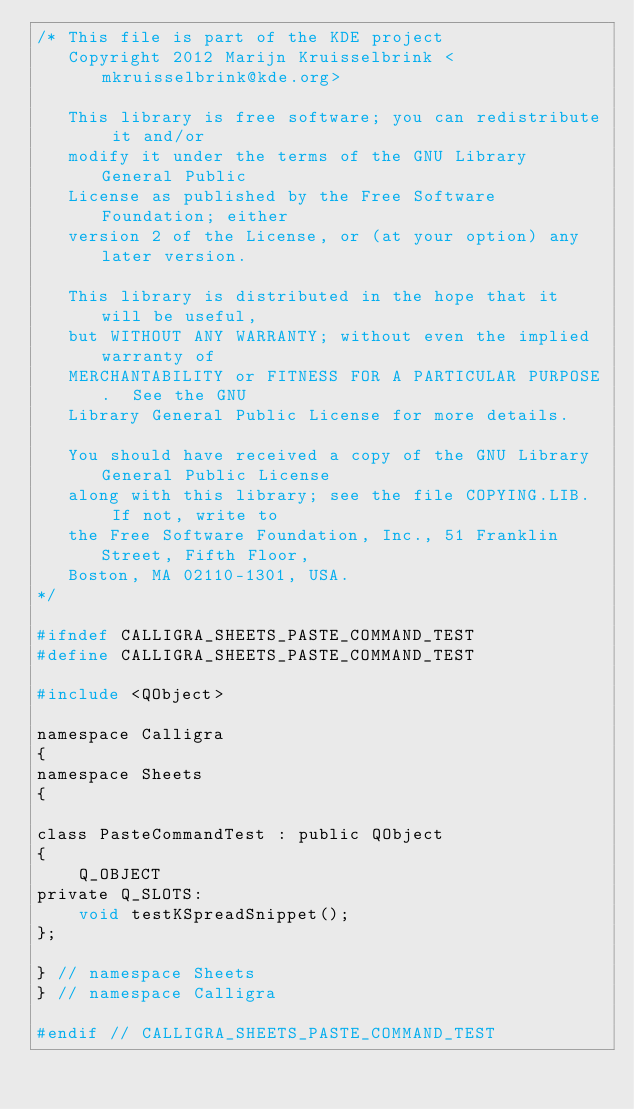Convert code to text. <code><loc_0><loc_0><loc_500><loc_500><_C_>/* This file is part of the KDE project
   Copyright 2012 Marijn Kruisselbrink <mkruisselbrink@kde.org>

   This library is free software; you can redistribute it and/or
   modify it under the terms of the GNU Library General Public
   License as published by the Free Software Foundation; either
   version 2 of the License, or (at your option) any later version.

   This library is distributed in the hope that it will be useful,
   but WITHOUT ANY WARRANTY; without even the implied warranty of
   MERCHANTABILITY or FITNESS FOR A PARTICULAR PURPOSE.  See the GNU
   Library General Public License for more details.

   You should have received a copy of the GNU Library General Public License
   along with this library; see the file COPYING.LIB.  If not, write to
   the Free Software Foundation, Inc., 51 Franklin Street, Fifth Floor,
   Boston, MA 02110-1301, USA.
*/

#ifndef CALLIGRA_SHEETS_PASTE_COMMAND_TEST
#define CALLIGRA_SHEETS_PASTE_COMMAND_TEST

#include <QObject>

namespace Calligra
{
namespace Sheets
{

class PasteCommandTest : public QObject
{
    Q_OBJECT
private Q_SLOTS:
    void testKSpreadSnippet();
};

} // namespace Sheets
} // namespace Calligra

#endif // CALLIGRA_SHEETS_PASTE_COMMAND_TEST
</code> 